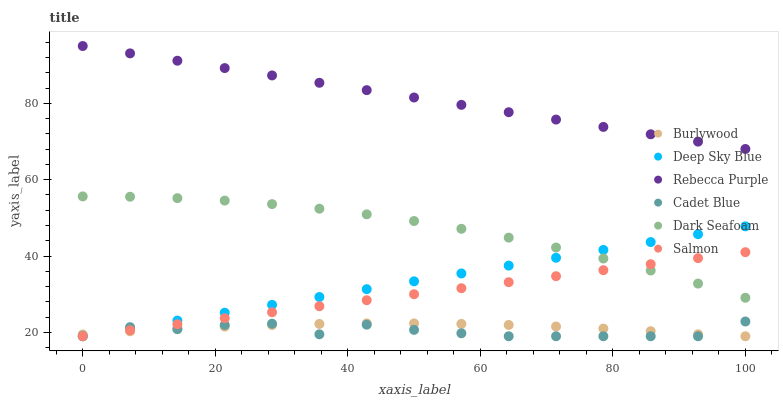Does Cadet Blue have the minimum area under the curve?
Answer yes or no. Yes. Does Rebecca Purple have the maximum area under the curve?
Answer yes or no. Yes. Does Burlywood have the minimum area under the curve?
Answer yes or no. No. Does Burlywood have the maximum area under the curve?
Answer yes or no. No. Is Salmon the smoothest?
Answer yes or no. Yes. Is Cadet Blue the roughest?
Answer yes or no. Yes. Is Burlywood the smoothest?
Answer yes or no. No. Is Burlywood the roughest?
Answer yes or no. No. Does Cadet Blue have the lowest value?
Answer yes or no. Yes. Does Dark Seafoam have the lowest value?
Answer yes or no. No. Does Rebecca Purple have the highest value?
Answer yes or no. Yes. Does Salmon have the highest value?
Answer yes or no. No. Is Deep Sky Blue less than Rebecca Purple?
Answer yes or no. Yes. Is Rebecca Purple greater than Cadet Blue?
Answer yes or no. Yes. Does Burlywood intersect Deep Sky Blue?
Answer yes or no. Yes. Is Burlywood less than Deep Sky Blue?
Answer yes or no. No. Is Burlywood greater than Deep Sky Blue?
Answer yes or no. No. Does Deep Sky Blue intersect Rebecca Purple?
Answer yes or no. No. 